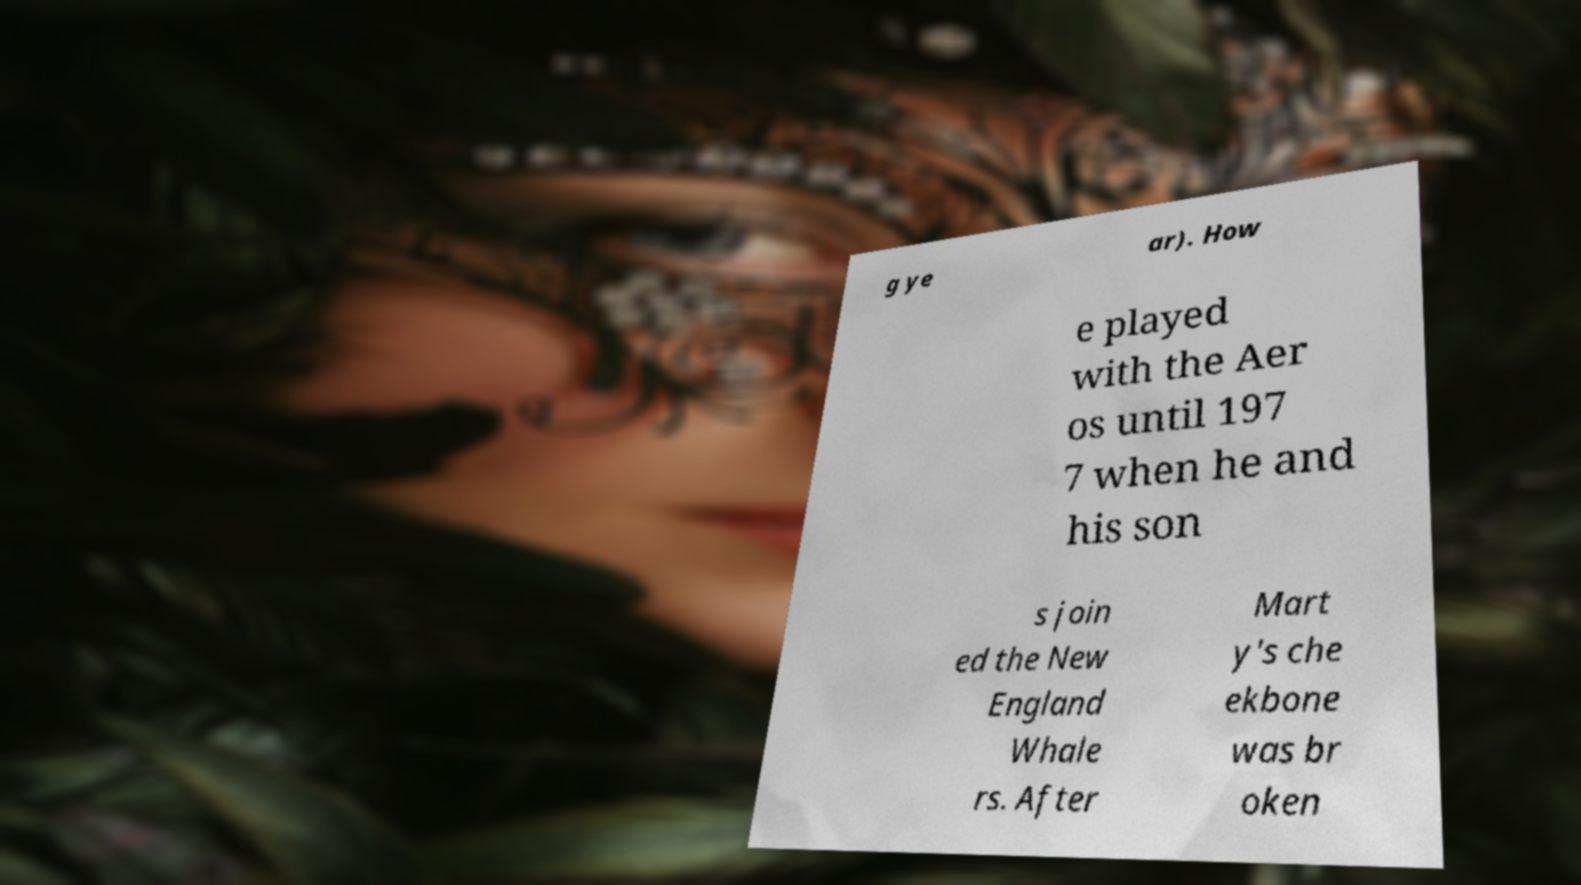What story does this text combined with the image seem to suggest? The text appears to narrate part of a story about a person who played with the Aeros until 1977, then joined the New England Whalers with his sons, and suffered an injury. The image of a veiled figure with an obscured face might suggest a theme of mystery or hidden aspects, implying a deeper, perhaps untold story about this individual's experiences and challenges in life. 